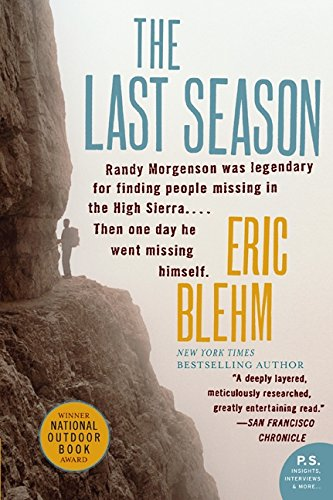What is the title of this book? The title of the book shown in the image is 'The Last Season (P.S.)'. 